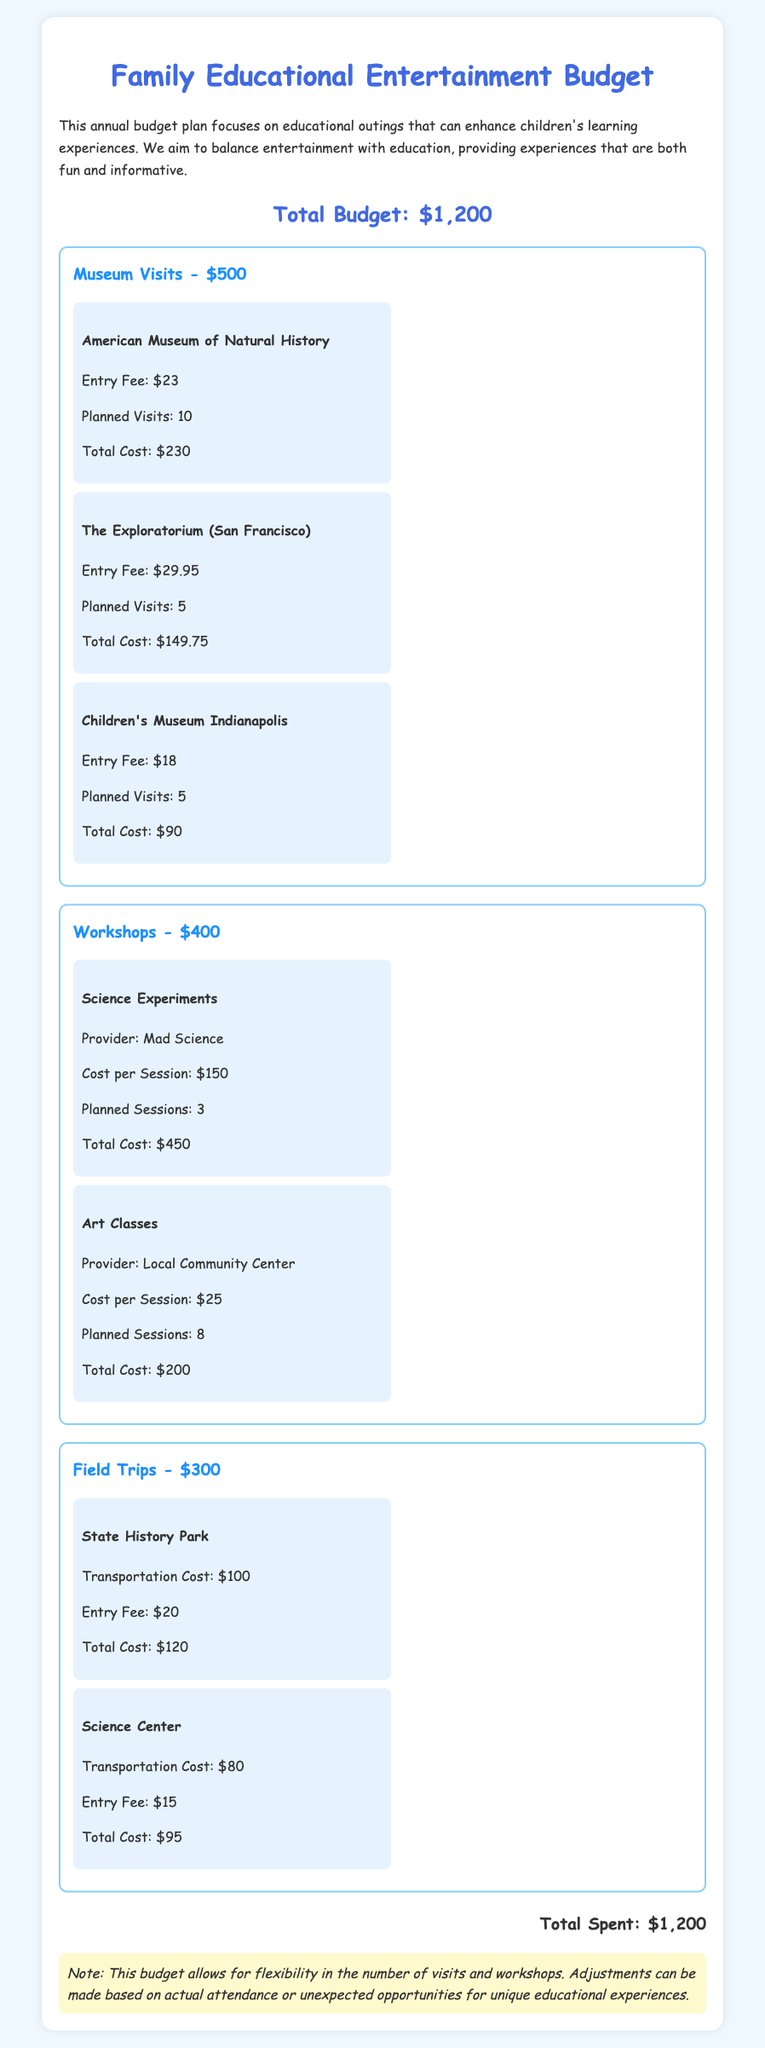What is the total budget? The total budget is clearly stated at the beginning of the document.
Answer: $1,200 How many planned visits are there to the American Museum of Natural History? The number of planned visits is provided under the specific item for the museum.
Answer: 10 What is the total cost for art classes? The total cost can be calculated from the cost per session and the planned sessions mentioned in the art classes section.
Answer: $200 What is the entry fee for The Exploratorium? The document specifies the entry fee under the details for The Exploratorium.
Answer: $29.95 What is the total cost for science experiments? The total cost is calculated based on the cost per session and planned sessions for science experiments.
Answer: $450 How much is allocated for museum visits? The budget section clearly allocates a portion of the total budget specifically for museum visits.
Answer: $500 Which workshop provider offers science experiments? The workshop provider is listed in the specific item for science experiments in the document.
Answer: Mad Science What is the transportation cost for the Science Center field trip? The transportation cost is detailed in the specific item for the Science Center field trip.
Answer: $80 How many planned sessions are there for workshops total? The total planned sessions can be summed from both workshop categories.
Answer: 11 